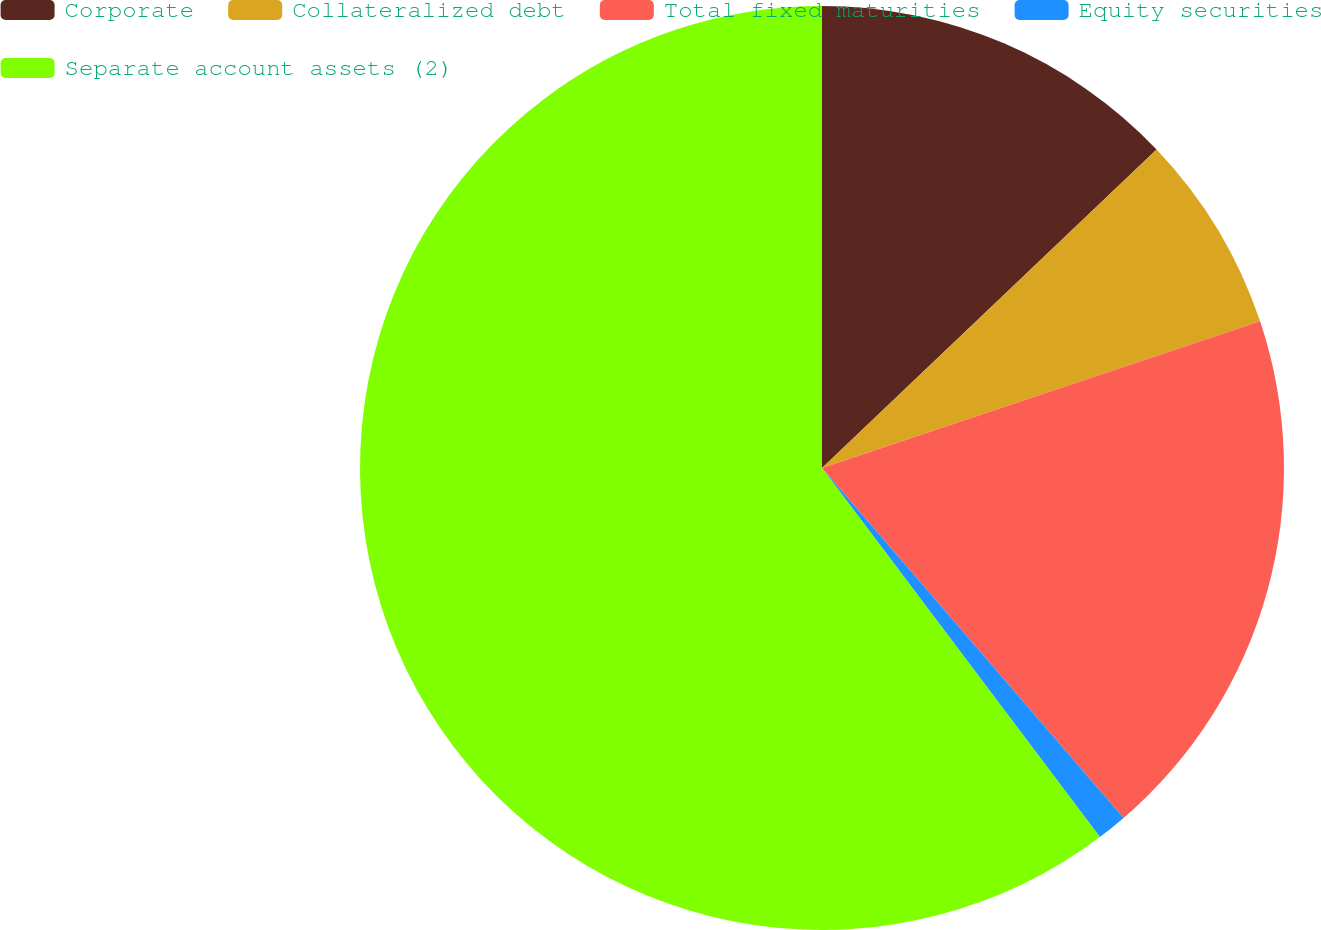Convert chart. <chart><loc_0><loc_0><loc_500><loc_500><pie_chart><fcel>Corporate<fcel>Collateralized debt<fcel>Total fixed maturities<fcel>Equity securities<fcel>Separate account assets (2)<nl><fcel>12.89%<fcel>6.97%<fcel>18.82%<fcel>1.05%<fcel>60.27%<nl></chart> 